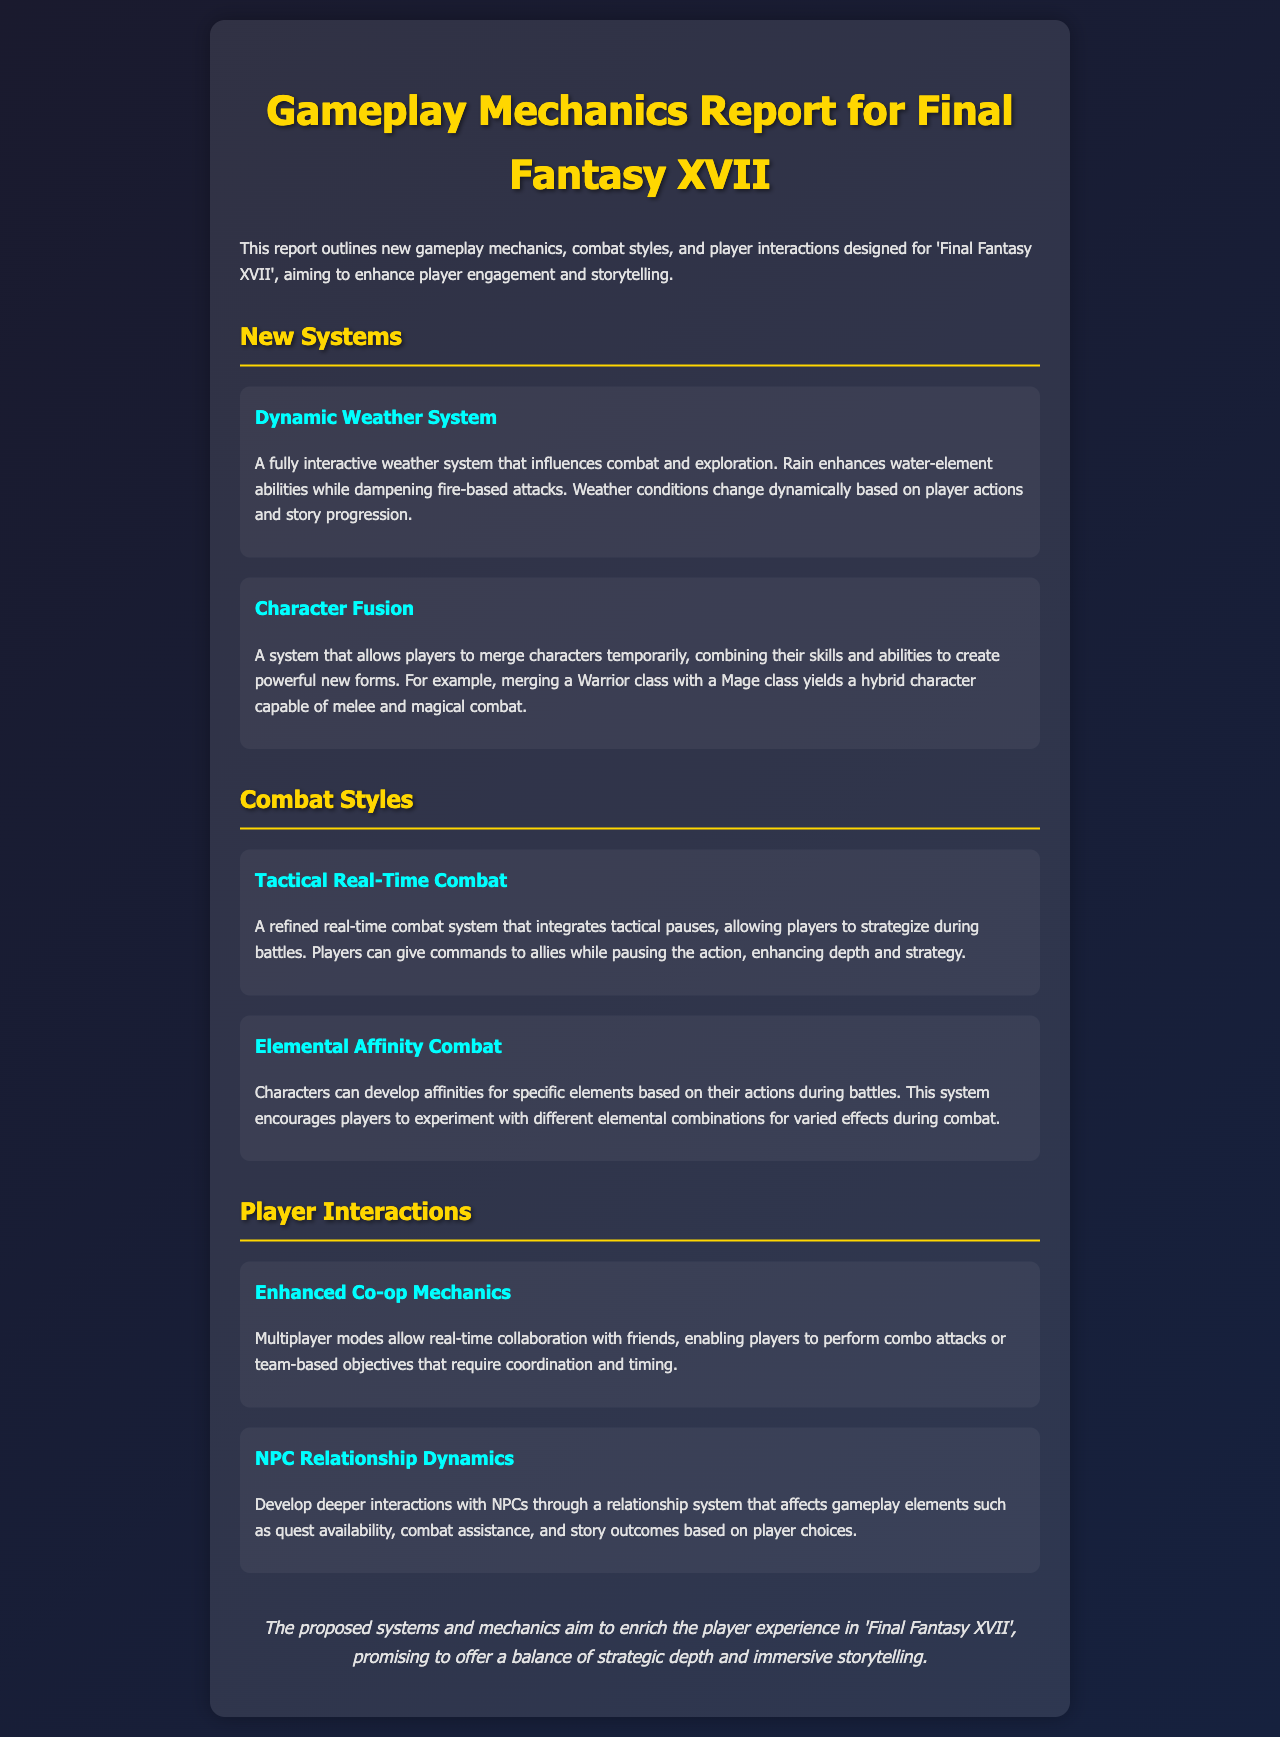What is the title of the report? The title of the report, as mentioned in the document, identifies the content and purpose of the document.
Answer: Gameplay Mechanics Report for Final Fantasy XVII What new system involves changing weather? The report details several systems, and one of them specifically mentions weather variations affecting gameplay.
Answer: Dynamic Weather System What allows players to merge characters? The document discusses a system that enables a combination of characters and their abilities which creates new forms.
Answer: Character Fusion What type of combat system is described as tactical? The report describes combat systems, one of which specifically mentions tactical elements combined with real-time action.
Answer: Tactical Real-Time Combat How do characters develop affinities in combat? The report explains that characters can develop affinities for elements, which are based on their actions during battles.
Answer: Based on their actions What type of multiplayer mechanics are enhanced? The document mentions a specific gameplay feature that improves interaction during multiplayer gameplay.
Answer: Enhanced Co-op Mechanics What impacts quest availability according to the report? The report outlines how relationships with NPCs affect various gameplay elements, including quest availability.
Answer: NPC Relationship Dynamics How does weather influence combat styles? The report states that the weather can enhance or dampen specific abilities depending on its state.
Answer: Enhances water-element abilities, dampens fire-based attacks What gameplay element is affected by player choices? The document discusses a feature related to NPC interactions and how they can change due to player decisions.
Answer: Story outcomes 